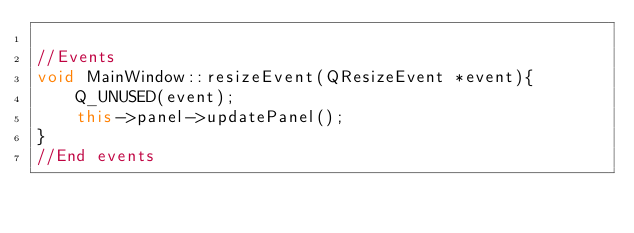<code> <loc_0><loc_0><loc_500><loc_500><_C++_>
//Events
void MainWindow::resizeEvent(QResizeEvent *event){
    Q_UNUSED(event);
    this->panel->updatePanel();
}
//End events
</code> 